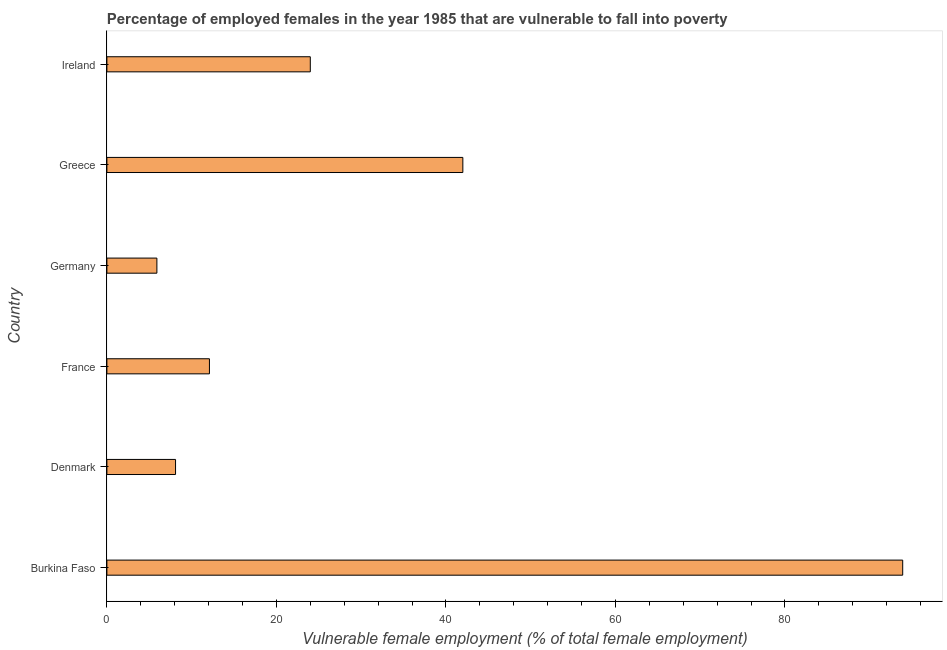Does the graph contain any zero values?
Offer a terse response. No. What is the title of the graph?
Your response must be concise. Percentage of employed females in the year 1985 that are vulnerable to fall into poverty. What is the label or title of the X-axis?
Your response must be concise. Vulnerable female employment (% of total female employment). What is the percentage of employed females who are vulnerable to fall into poverty in Denmark?
Provide a short and direct response. 8.1. Across all countries, what is the maximum percentage of employed females who are vulnerable to fall into poverty?
Keep it short and to the point. 93.9. Across all countries, what is the minimum percentage of employed females who are vulnerable to fall into poverty?
Your response must be concise. 5.9. In which country was the percentage of employed females who are vulnerable to fall into poverty maximum?
Give a very brief answer. Burkina Faso. What is the sum of the percentage of employed females who are vulnerable to fall into poverty?
Offer a very short reply. 186. What is the average percentage of employed females who are vulnerable to fall into poverty per country?
Offer a very short reply. 31. What is the median percentage of employed females who are vulnerable to fall into poverty?
Keep it short and to the point. 18.05. In how many countries, is the percentage of employed females who are vulnerable to fall into poverty greater than 44 %?
Give a very brief answer. 1. What is the ratio of the percentage of employed females who are vulnerable to fall into poverty in France to that in Germany?
Ensure brevity in your answer.  2.05. What is the difference between the highest and the second highest percentage of employed females who are vulnerable to fall into poverty?
Offer a terse response. 51.9. What is the difference between the highest and the lowest percentage of employed females who are vulnerable to fall into poverty?
Offer a terse response. 88. In how many countries, is the percentage of employed females who are vulnerable to fall into poverty greater than the average percentage of employed females who are vulnerable to fall into poverty taken over all countries?
Give a very brief answer. 2. Are all the bars in the graph horizontal?
Provide a succinct answer. Yes. How many countries are there in the graph?
Make the answer very short. 6. Are the values on the major ticks of X-axis written in scientific E-notation?
Offer a very short reply. No. What is the Vulnerable female employment (% of total female employment) of Burkina Faso?
Provide a short and direct response. 93.9. What is the Vulnerable female employment (% of total female employment) of Denmark?
Provide a succinct answer. 8.1. What is the Vulnerable female employment (% of total female employment) of France?
Provide a succinct answer. 12.1. What is the Vulnerable female employment (% of total female employment) of Germany?
Make the answer very short. 5.9. What is the Vulnerable female employment (% of total female employment) in Greece?
Keep it short and to the point. 42. What is the difference between the Vulnerable female employment (% of total female employment) in Burkina Faso and Denmark?
Offer a terse response. 85.8. What is the difference between the Vulnerable female employment (% of total female employment) in Burkina Faso and France?
Your response must be concise. 81.8. What is the difference between the Vulnerable female employment (% of total female employment) in Burkina Faso and Germany?
Give a very brief answer. 88. What is the difference between the Vulnerable female employment (% of total female employment) in Burkina Faso and Greece?
Keep it short and to the point. 51.9. What is the difference between the Vulnerable female employment (% of total female employment) in Burkina Faso and Ireland?
Your answer should be very brief. 69.9. What is the difference between the Vulnerable female employment (% of total female employment) in Denmark and Greece?
Your answer should be very brief. -33.9. What is the difference between the Vulnerable female employment (% of total female employment) in Denmark and Ireland?
Give a very brief answer. -15.9. What is the difference between the Vulnerable female employment (% of total female employment) in France and Germany?
Ensure brevity in your answer.  6.2. What is the difference between the Vulnerable female employment (% of total female employment) in France and Greece?
Offer a very short reply. -29.9. What is the difference between the Vulnerable female employment (% of total female employment) in France and Ireland?
Offer a terse response. -11.9. What is the difference between the Vulnerable female employment (% of total female employment) in Germany and Greece?
Give a very brief answer. -36.1. What is the difference between the Vulnerable female employment (% of total female employment) in Germany and Ireland?
Offer a very short reply. -18.1. What is the ratio of the Vulnerable female employment (% of total female employment) in Burkina Faso to that in Denmark?
Your answer should be very brief. 11.59. What is the ratio of the Vulnerable female employment (% of total female employment) in Burkina Faso to that in France?
Ensure brevity in your answer.  7.76. What is the ratio of the Vulnerable female employment (% of total female employment) in Burkina Faso to that in Germany?
Your response must be concise. 15.91. What is the ratio of the Vulnerable female employment (% of total female employment) in Burkina Faso to that in Greece?
Provide a succinct answer. 2.24. What is the ratio of the Vulnerable female employment (% of total female employment) in Burkina Faso to that in Ireland?
Give a very brief answer. 3.91. What is the ratio of the Vulnerable female employment (% of total female employment) in Denmark to that in France?
Provide a short and direct response. 0.67. What is the ratio of the Vulnerable female employment (% of total female employment) in Denmark to that in Germany?
Give a very brief answer. 1.37. What is the ratio of the Vulnerable female employment (% of total female employment) in Denmark to that in Greece?
Keep it short and to the point. 0.19. What is the ratio of the Vulnerable female employment (% of total female employment) in Denmark to that in Ireland?
Offer a very short reply. 0.34. What is the ratio of the Vulnerable female employment (% of total female employment) in France to that in Germany?
Keep it short and to the point. 2.05. What is the ratio of the Vulnerable female employment (% of total female employment) in France to that in Greece?
Your answer should be compact. 0.29. What is the ratio of the Vulnerable female employment (% of total female employment) in France to that in Ireland?
Your answer should be compact. 0.5. What is the ratio of the Vulnerable female employment (% of total female employment) in Germany to that in Greece?
Keep it short and to the point. 0.14. What is the ratio of the Vulnerable female employment (% of total female employment) in Germany to that in Ireland?
Your response must be concise. 0.25. What is the ratio of the Vulnerable female employment (% of total female employment) in Greece to that in Ireland?
Offer a terse response. 1.75. 